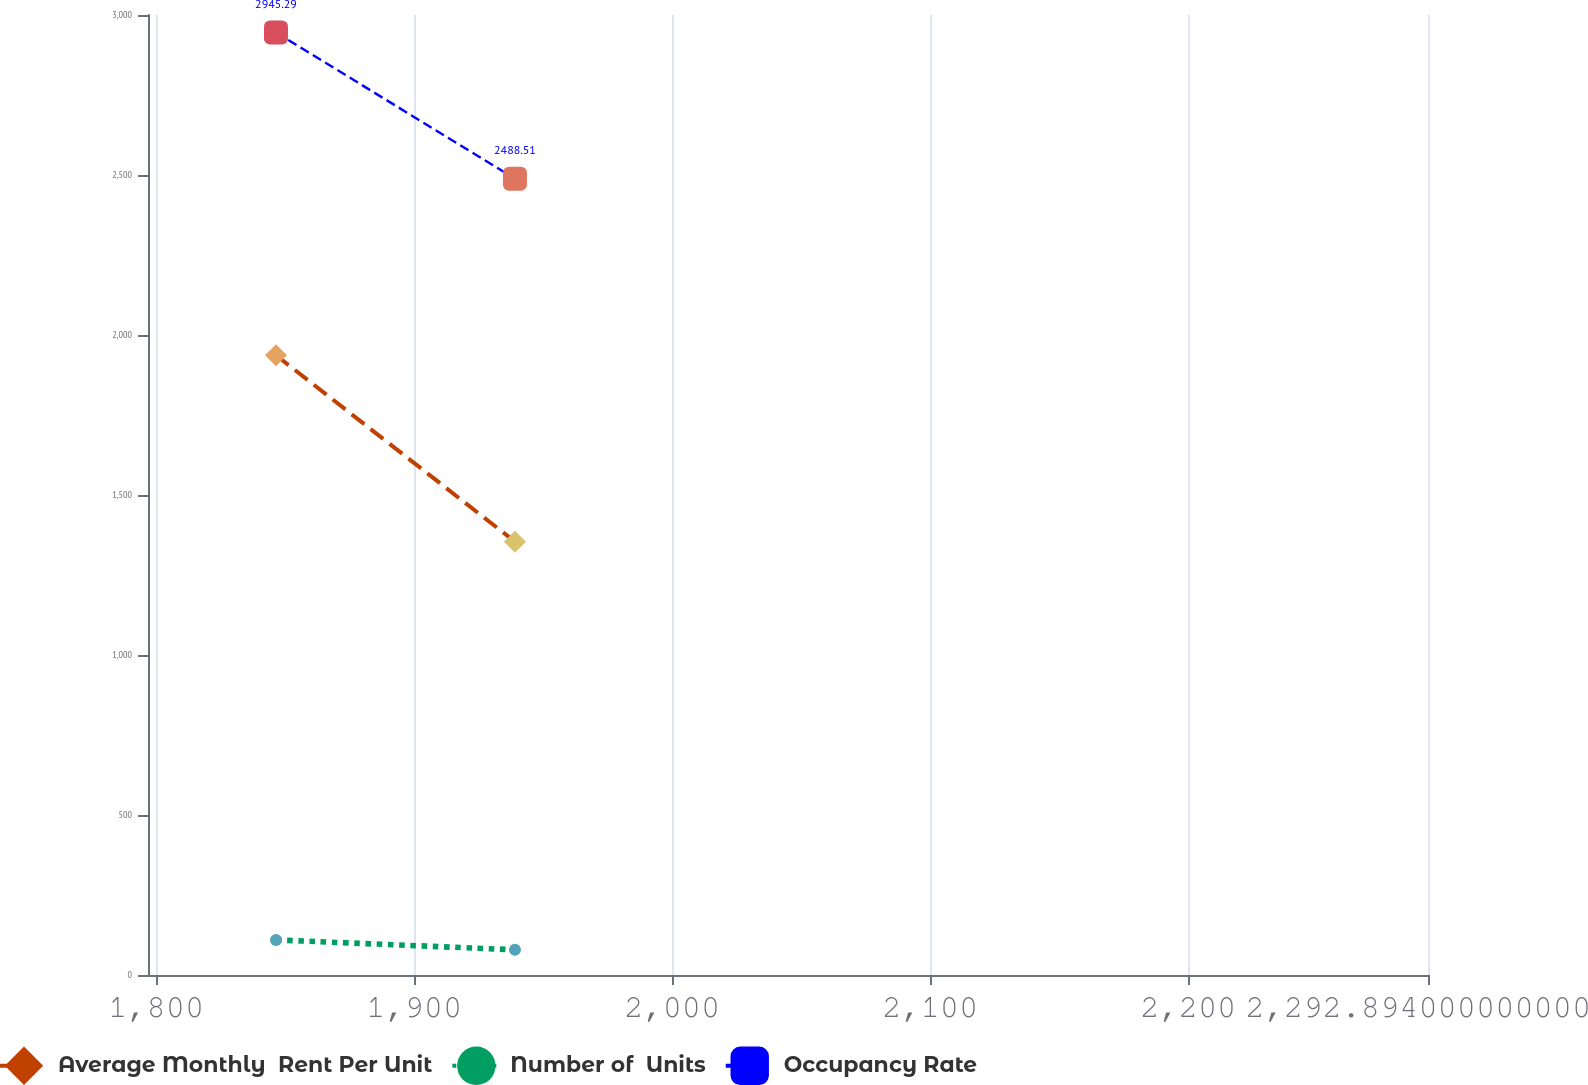Convert chart. <chart><loc_0><loc_0><loc_500><loc_500><line_chart><ecel><fcel>Average Monthly  Rent Per Unit<fcel>Number of  Units<fcel>Occupancy Rate<nl><fcel>1846.44<fcel>1936.68<fcel>109.67<fcel>2945.29<nl><fcel>1939.05<fcel>1354.18<fcel>78.81<fcel>2488.51<nl><fcel>2342.5<fcel>1882.51<fcel>100.86<fcel>2567.1<nl></chart> 